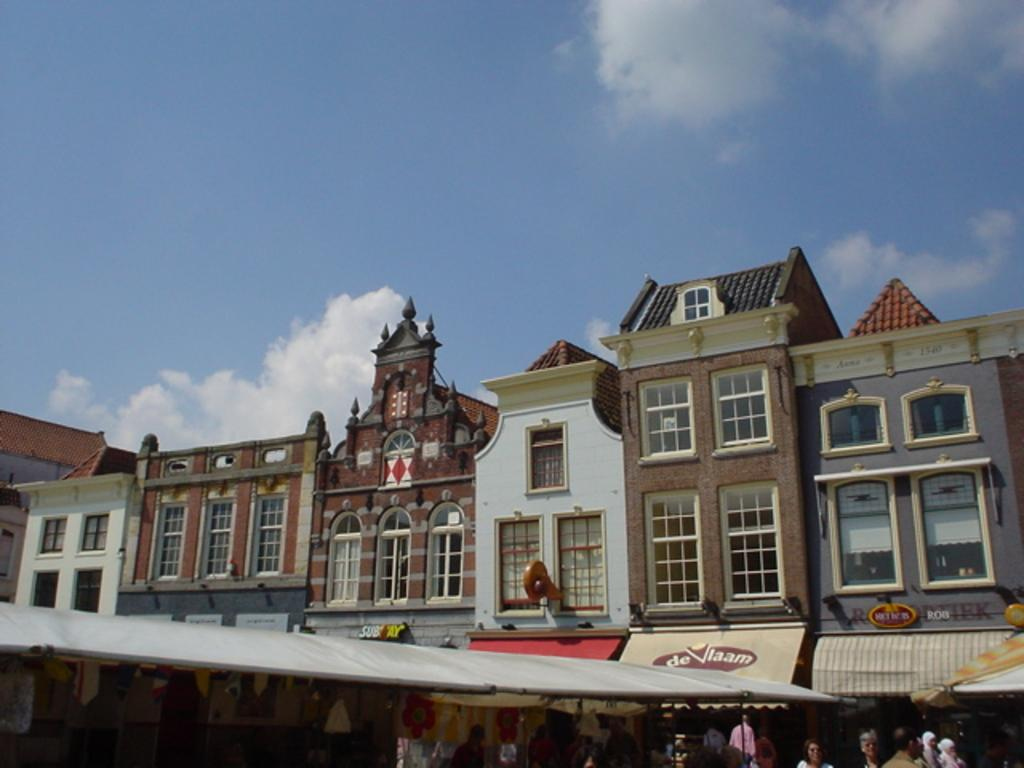What type of structures can be seen in the image? There are buildings in the image. What type of establishments can be found among the buildings? There are stores in the image. Are there any people visible in the image? Yes, there are persons in the image. What can be seen in the background of the image? The sky is visible in the image, and clouds are present in the sky. Where is the mailbox located in the image? There is no mailbox present in the image. Can you describe the relationship between the persons and their parents in the image? There is no information about the relationship between the persons and their parents in the image. 